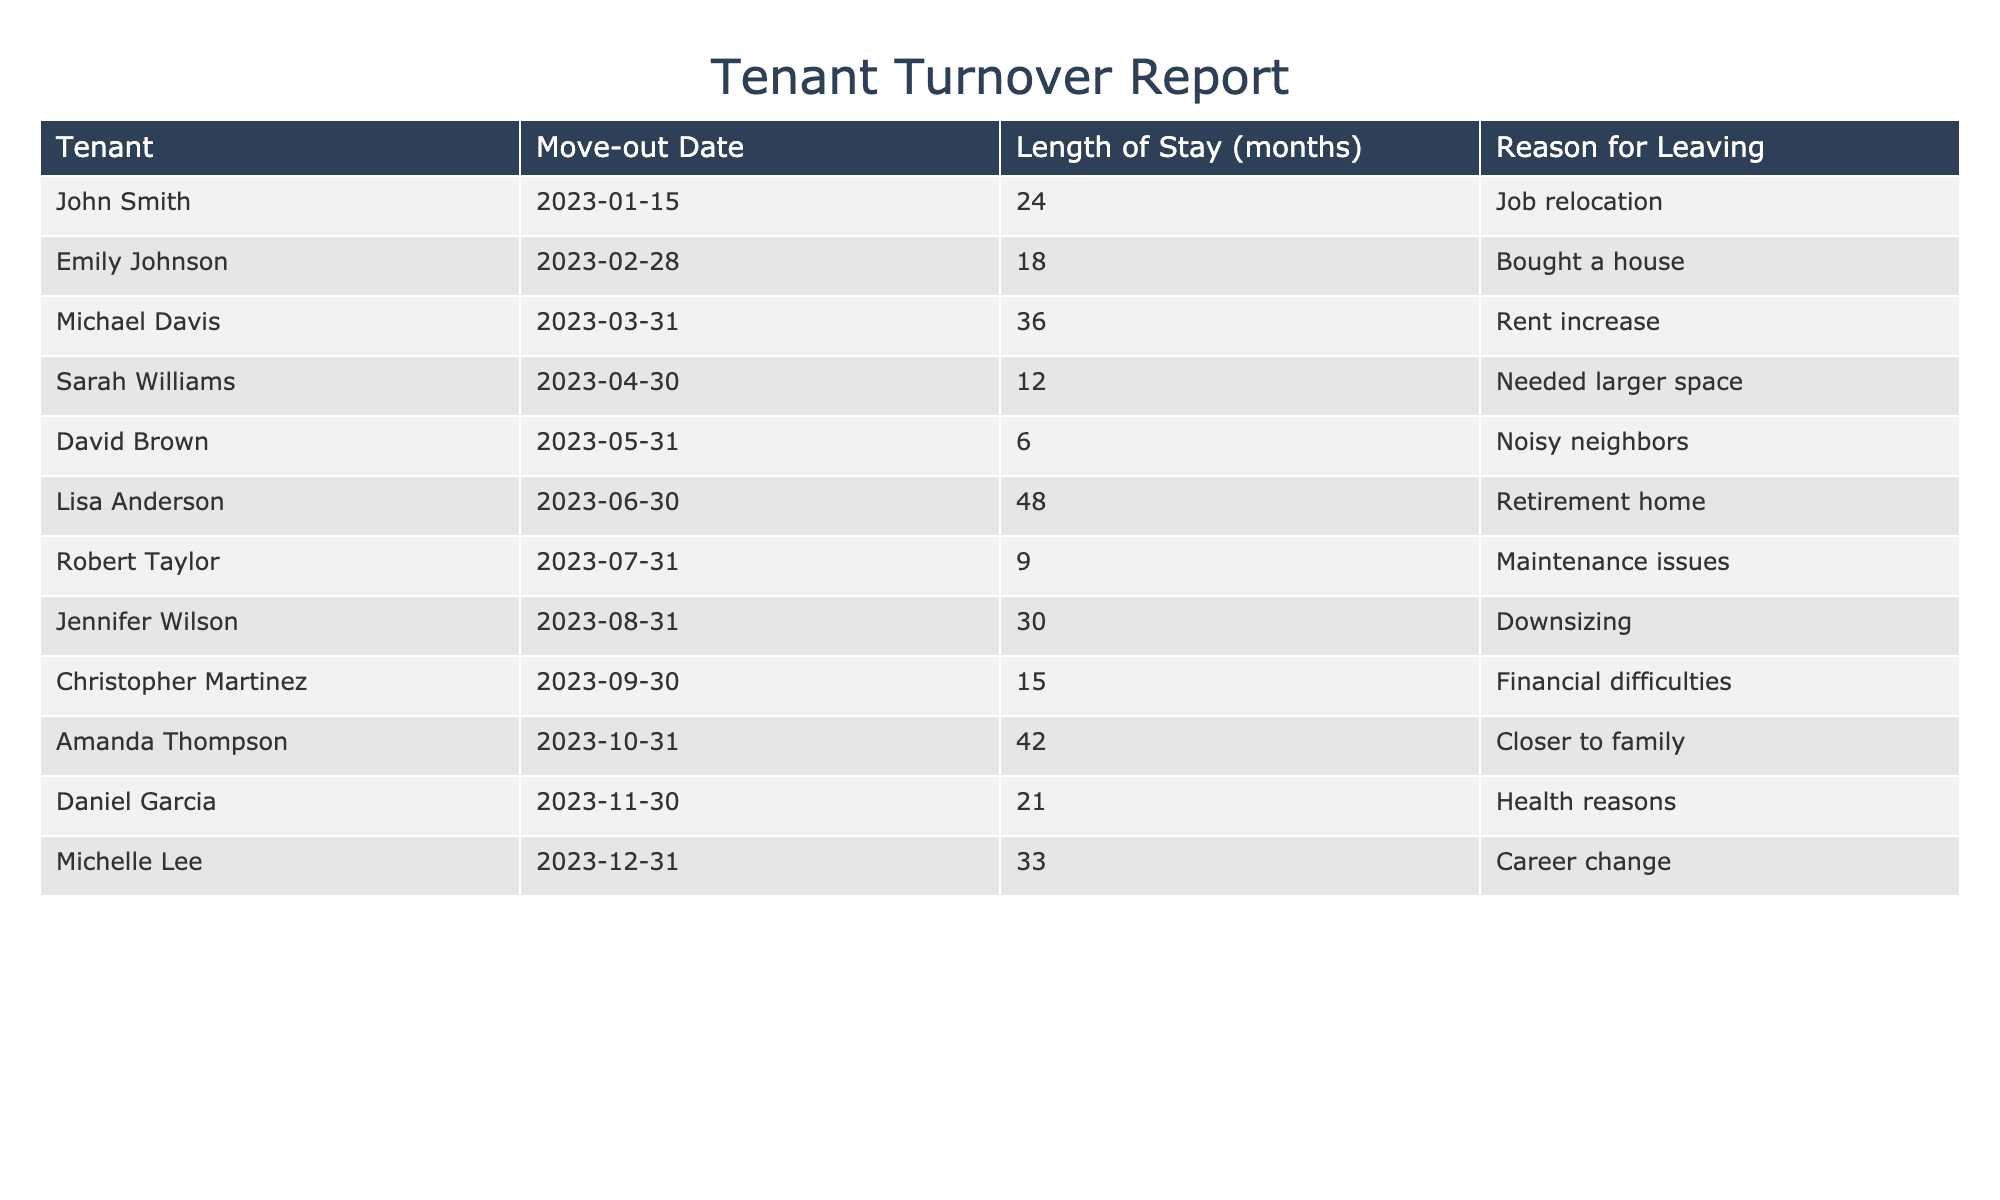What is the reason for Emily Johnson's departure? In the table, looking at Emily Johnson's entry, the reason for leaving is listed as "Bought a house."
Answer: Bought a house How long did David Brown stay before moving out? David Brown is noted to have a length of stay of 6 months in the table.
Answer: 6 months How many tenants left due to financial difficulties? In the table, Christopher Martinez is the only tenant who left due to "Financial difficulties," so the count is one.
Answer: 1 What is the average length of stay for all tenants who left due to maintenance issues? Robert Taylor left due to maintenance issues and his length of stay is 9 months. The average length of stay in this case is simply 9 months, since there is only one tenant in this category.
Answer: 9 months Was there any tenant who moved out for health reasons? Daniel Garcia is listed as leaving for "Health reasons," confirming that at least one tenant left for this reason.
Answer: Yes Which tenant stayed the longest, and how many months did they live there? In the table, Lisa Anderson stayed for 48 months, which is the longest stay recorded.
Answer: Lisa Anderson, 48 months How many tenants cited needing a bigger space as their reason for moving out? Sarah Williams is the only tenant noted for needing a larger space, so the count is one.
Answer: 1 What is the total number of tenants who left due to personal circumstances like job relocation, health reasons, or career change? John Smith (job relocation), Daniel Garcia (health reasons), and Michelle Lee (career change) account for three tenants who left for personal circumstances, making the total three.
Answer: 3 How many tenants have moved out in the last year as opposed to longer stays? There are 5 tenants with a stay of 12 months or less, indicating recent moves in the last year.
Answer: 5 tenants What was the most common reason for leaving among the tenants in the table? Analyzing the reasons for leaving, "Health reasons" and "Noisy neighbors," along with other categories, points to no predominant reason. Thus, multiple reasons are around.
Answer: Multiple reasons 